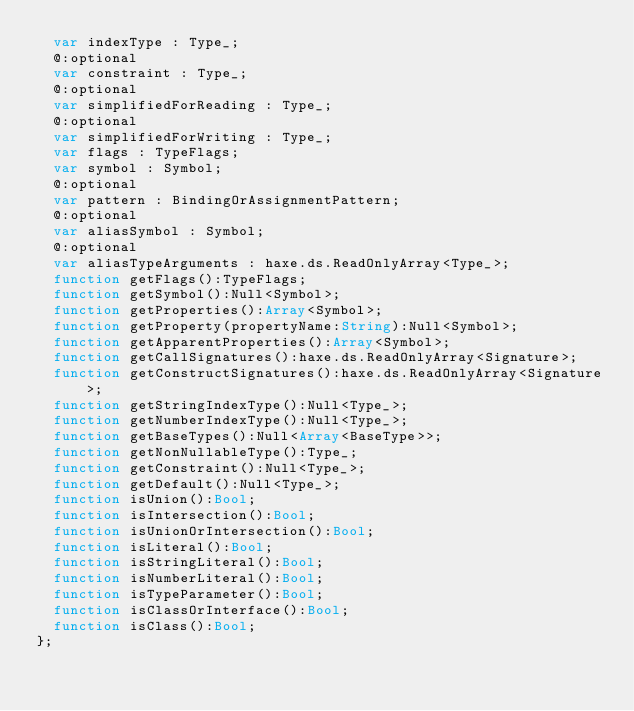Convert code to text. <code><loc_0><loc_0><loc_500><loc_500><_Haxe_>	var indexType : Type_;
	@:optional
	var constraint : Type_;
	@:optional
	var simplifiedForReading : Type_;
	@:optional
	var simplifiedForWriting : Type_;
	var flags : TypeFlags;
	var symbol : Symbol;
	@:optional
	var pattern : BindingOrAssignmentPattern;
	@:optional
	var aliasSymbol : Symbol;
	@:optional
	var aliasTypeArguments : haxe.ds.ReadOnlyArray<Type_>;
	function getFlags():TypeFlags;
	function getSymbol():Null<Symbol>;
	function getProperties():Array<Symbol>;
	function getProperty(propertyName:String):Null<Symbol>;
	function getApparentProperties():Array<Symbol>;
	function getCallSignatures():haxe.ds.ReadOnlyArray<Signature>;
	function getConstructSignatures():haxe.ds.ReadOnlyArray<Signature>;
	function getStringIndexType():Null<Type_>;
	function getNumberIndexType():Null<Type_>;
	function getBaseTypes():Null<Array<BaseType>>;
	function getNonNullableType():Type_;
	function getConstraint():Null<Type_>;
	function getDefault():Null<Type_>;
	function isUnion():Bool;
	function isIntersection():Bool;
	function isUnionOrIntersection():Bool;
	function isLiteral():Bool;
	function isStringLiteral():Bool;
	function isNumberLiteral():Bool;
	function isTypeParameter():Bool;
	function isClassOrInterface():Bool;
	function isClass():Bool;
};</code> 